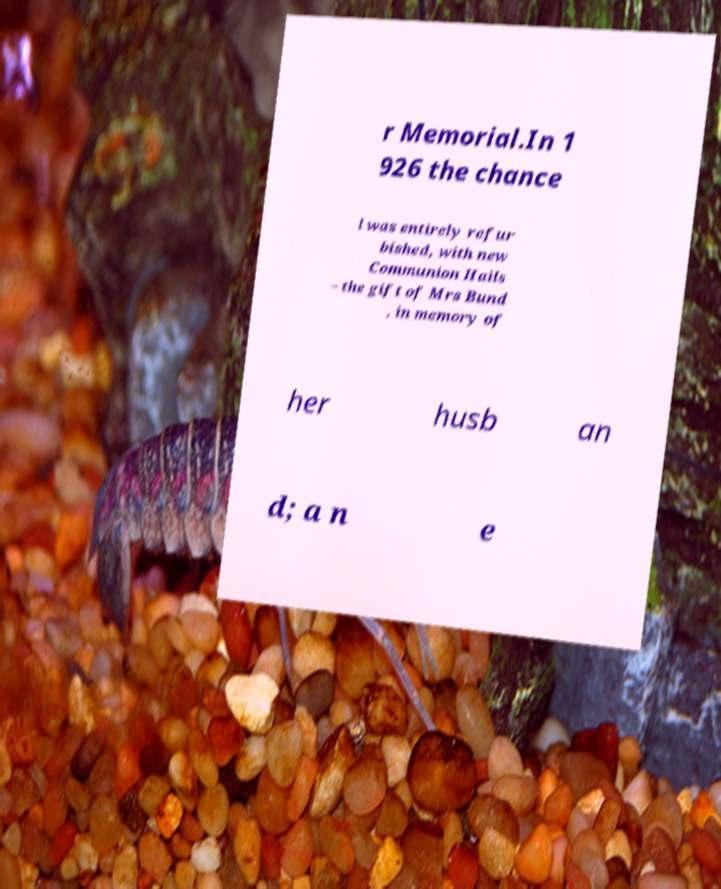I need the written content from this picture converted into text. Can you do that? r Memorial.In 1 926 the chance l was entirely refur bished, with new Communion Hails – the gift of Mrs Bund , in memory of her husb an d; a n e 